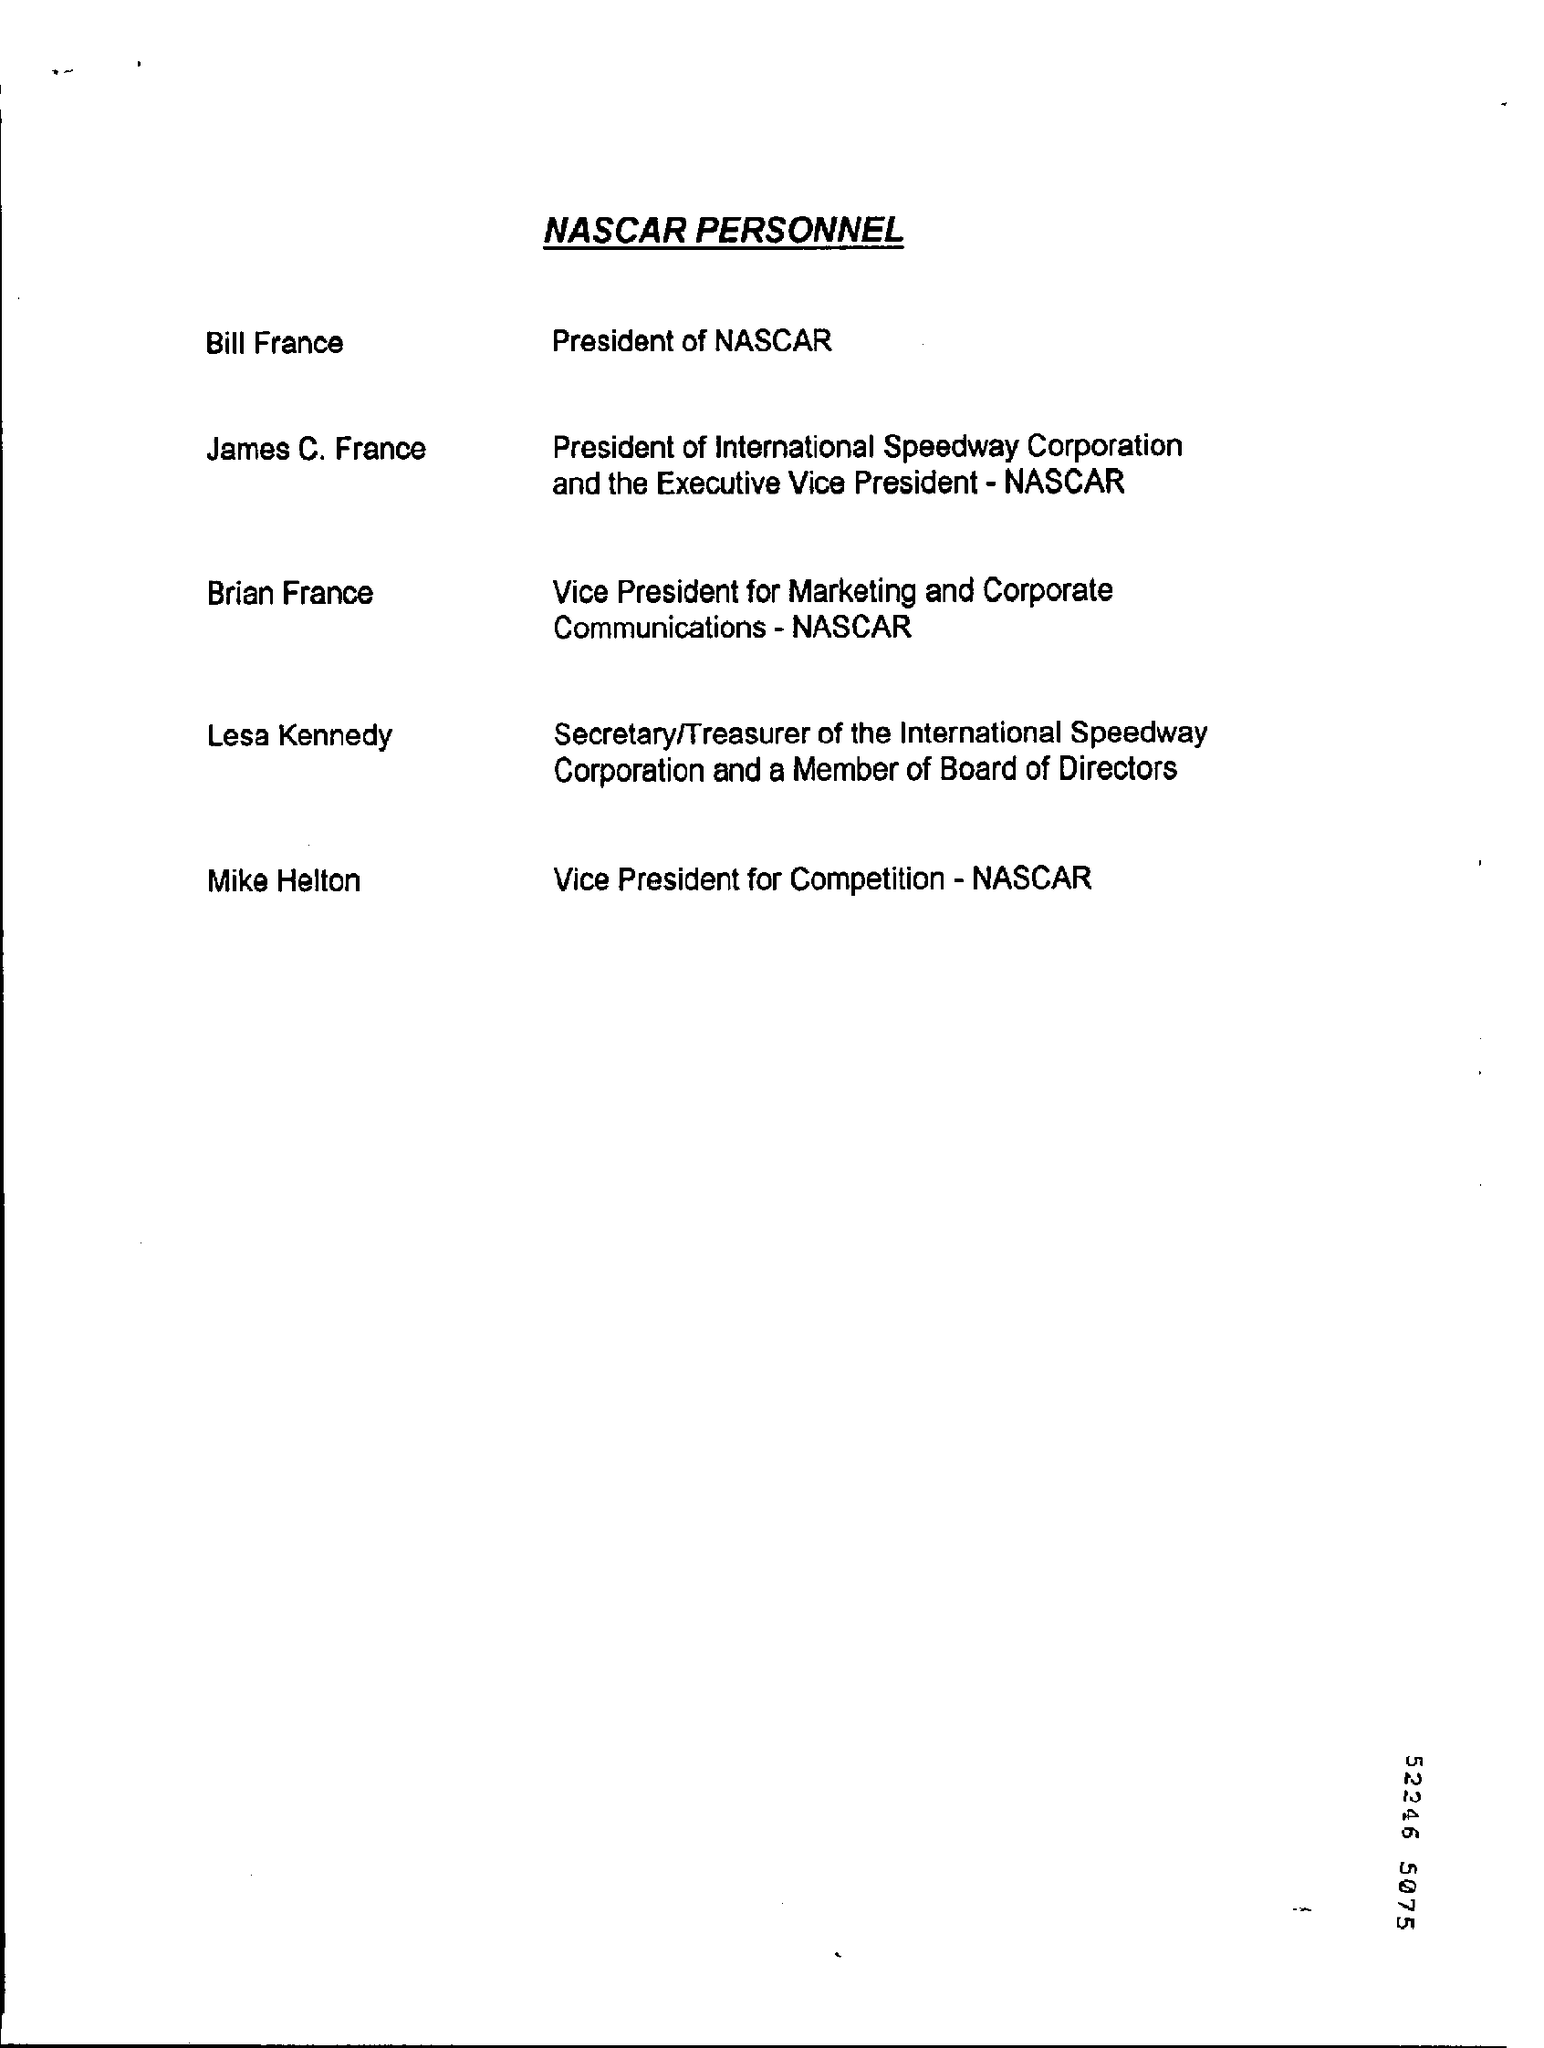Point out several critical features in this image. Mike Helton is the vice president of competition. 